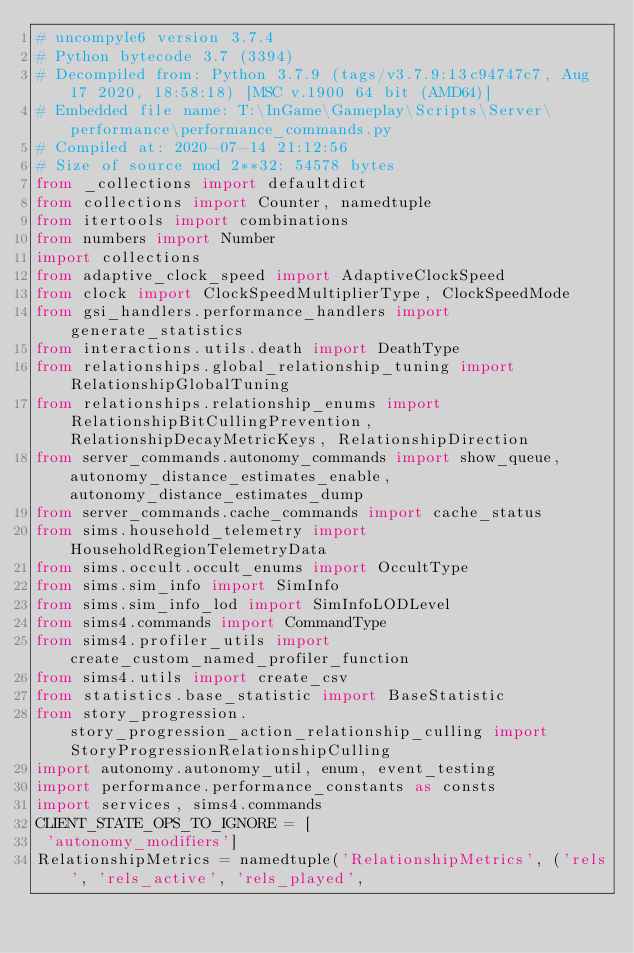Convert code to text. <code><loc_0><loc_0><loc_500><loc_500><_Python_># uncompyle6 version 3.7.4
# Python bytecode 3.7 (3394)
# Decompiled from: Python 3.7.9 (tags/v3.7.9:13c94747c7, Aug 17 2020, 18:58:18) [MSC v.1900 64 bit (AMD64)]
# Embedded file name: T:\InGame\Gameplay\Scripts\Server\performance\performance_commands.py
# Compiled at: 2020-07-14 21:12:56
# Size of source mod 2**32: 54578 bytes
from _collections import defaultdict
from collections import Counter, namedtuple
from itertools import combinations
from numbers import Number
import collections
from adaptive_clock_speed import AdaptiveClockSpeed
from clock import ClockSpeedMultiplierType, ClockSpeedMode
from gsi_handlers.performance_handlers import generate_statistics
from interactions.utils.death import DeathType
from relationships.global_relationship_tuning import RelationshipGlobalTuning
from relationships.relationship_enums import RelationshipBitCullingPrevention, RelationshipDecayMetricKeys, RelationshipDirection
from server_commands.autonomy_commands import show_queue, autonomy_distance_estimates_enable, autonomy_distance_estimates_dump
from server_commands.cache_commands import cache_status
from sims.household_telemetry import HouseholdRegionTelemetryData
from sims.occult.occult_enums import OccultType
from sims.sim_info import SimInfo
from sims.sim_info_lod import SimInfoLODLevel
from sims4.commands import CommandType
from sims4.profiler_utils import create_custom_named_profiler_function
from sims4.utils import create_csv
from statistics.base_statistic import BaseStatistic
from story_progression.story_progression_action_relationship_culling import StoryProgressionRelationshipCulling
import autonomy.autonomy_util, enum, event_testing
import performance.performance_constants as consts
import services, sims4.commands
CLIENT_STATE_OPS_TO_IGNORE = [
 'autonomy_modifiers']
RelationshipMetrics = namedtuple('RelationshipMetrics', ('rels', 'rels_active', 'rels_played',</code> 